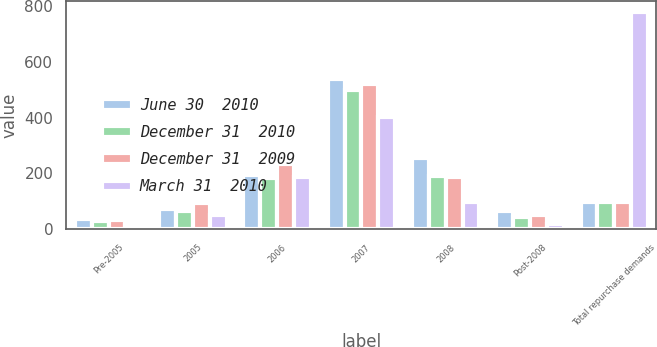Convert chart to OTSL. <chart><loc_0><loc_0><loc_500><loc_500><stacked_bar_chart><ecel><fcel>Pre-2005<fcel>2005<fcel>2006<fcel>2007<fcel>2008<fcel>Post-2008<fcel>Total repurchase demands<nl><fcel>June 30  2010<fcel>38<fcel>72<fcel>195<fcel>537<fcel>254<fcel>65<fcel>98<nl><fcel>December 31  2010<fcel>31<fcel>67<fcel>185<fcel>498<fcel>191<fcel>46<fcel>98<nl><fcel>December 31  2009<fcel>35<fcel>94<fcel>234<fcel>521<fcel>186<fcel>53<fcel>98<nl><fcel>March 31  2010<fcel>16<fcel>50<fcel>189<fcel>403<fcel>98<fcel>20<fcel>776<nl></chart> 